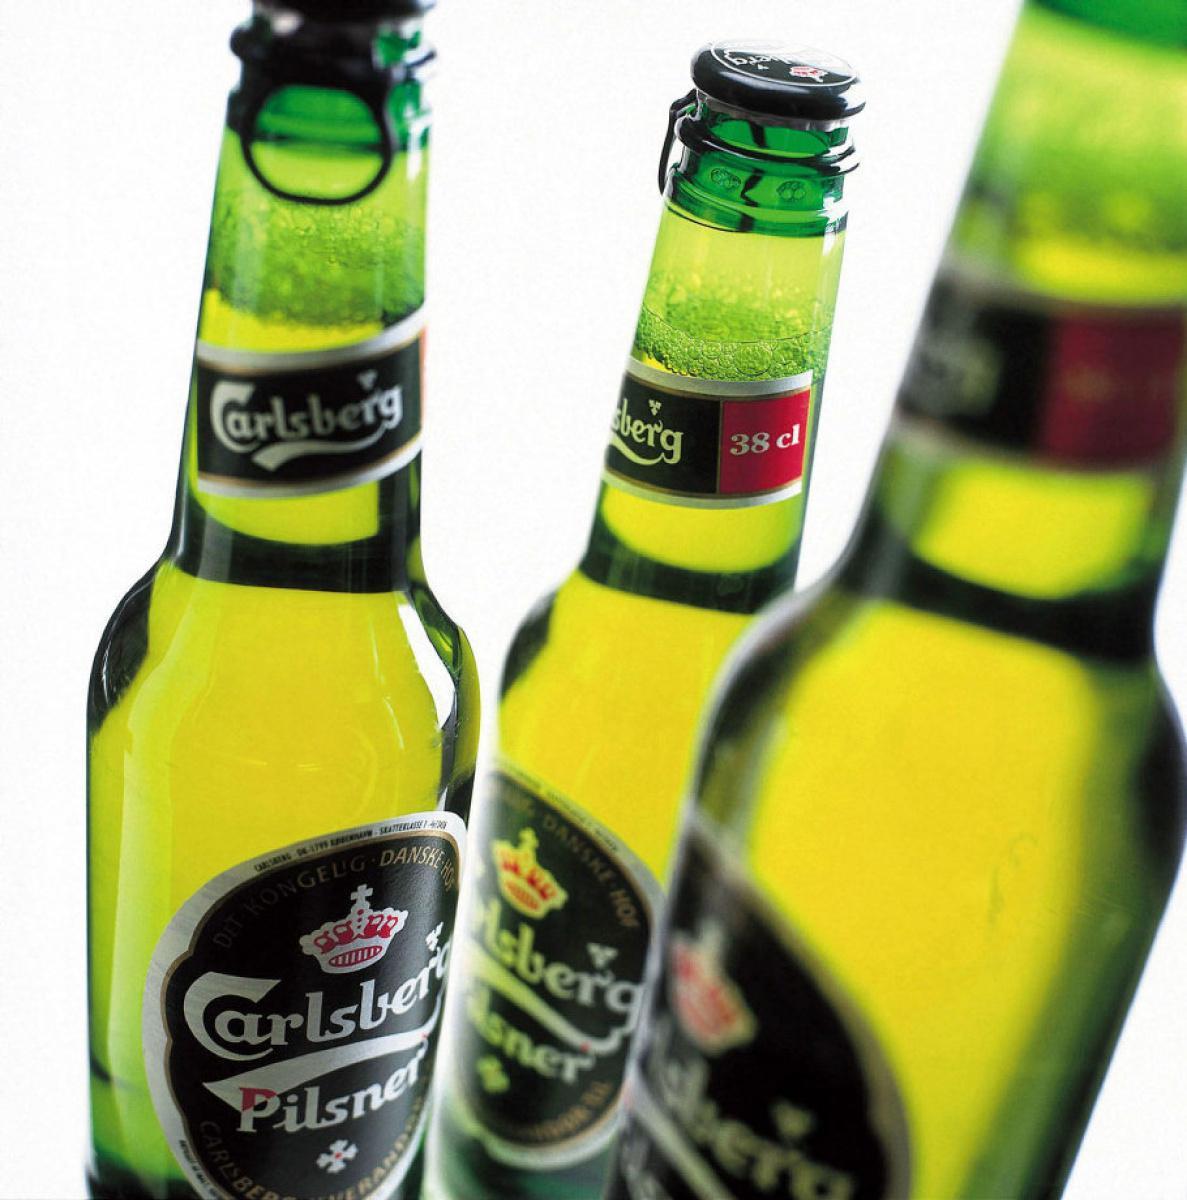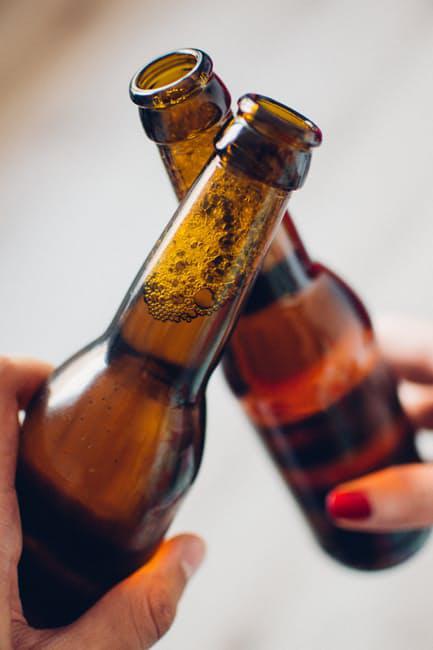The first image is the image on the left, the second image is the image on the right. For the images shown, is this caption "Both images are taken outdoors and in at least one of them, a campfire with food is in the background." true? Answer yes or no. No. The first image is the image on the left, the second image is the image on the right. Evaluate the accuracy of this statement regarding the images: "People are clinking two brown bottles together in one of the images.". Is it true? Answer yes or no. Yes. 